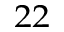Convert formula to latex. <formula><loc_0><loc_0><loc_500><loc_500>^ { 2 2 }</formula> 